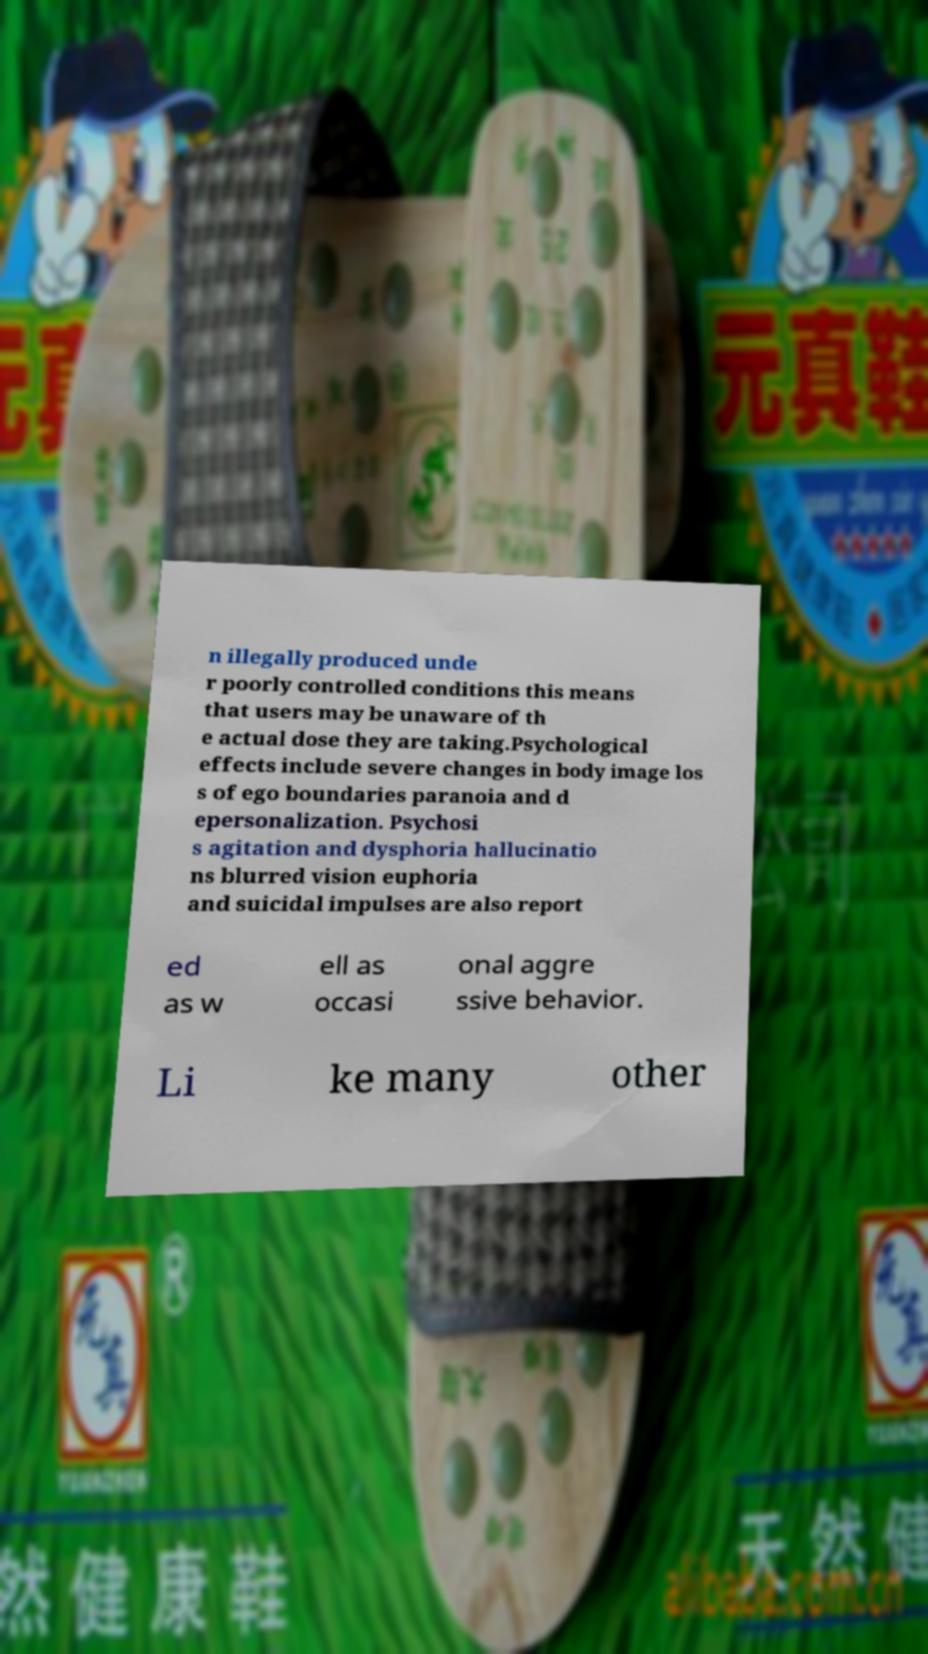Can you read and provide the text displayed in the image?This photo seems to have some interesting text. Can you extract and type it out for me? n illegally produced unde r poorly controlled conditions this means that users may be unaware of th e actual dose they are taking.Psychological effects include severe changes in body image los s of ego boundaries paranoia and d epersonalization. Psychosi s agitation and dysphoria hallucinatio ns blurred vision euphoria and suicidal impulses are also report ed as w ell as occasi onal aggre ssive behavior. Li ke many other 